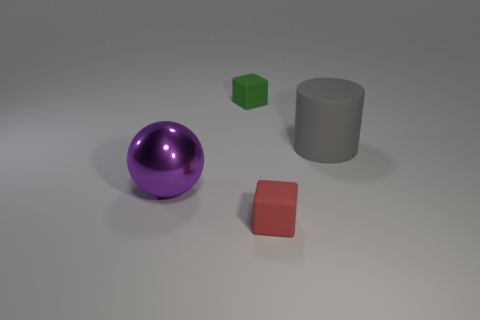How do the textures of the objects in the image compare? The objects in the image appear to have different textures. The purple sphere has a shiny, reflective surface, indicating a smooth texture, while the green cube and the gray cylinder seem to have a matte finish, suggesting a more diffuse reflection and likely a slightly rougher texture. 